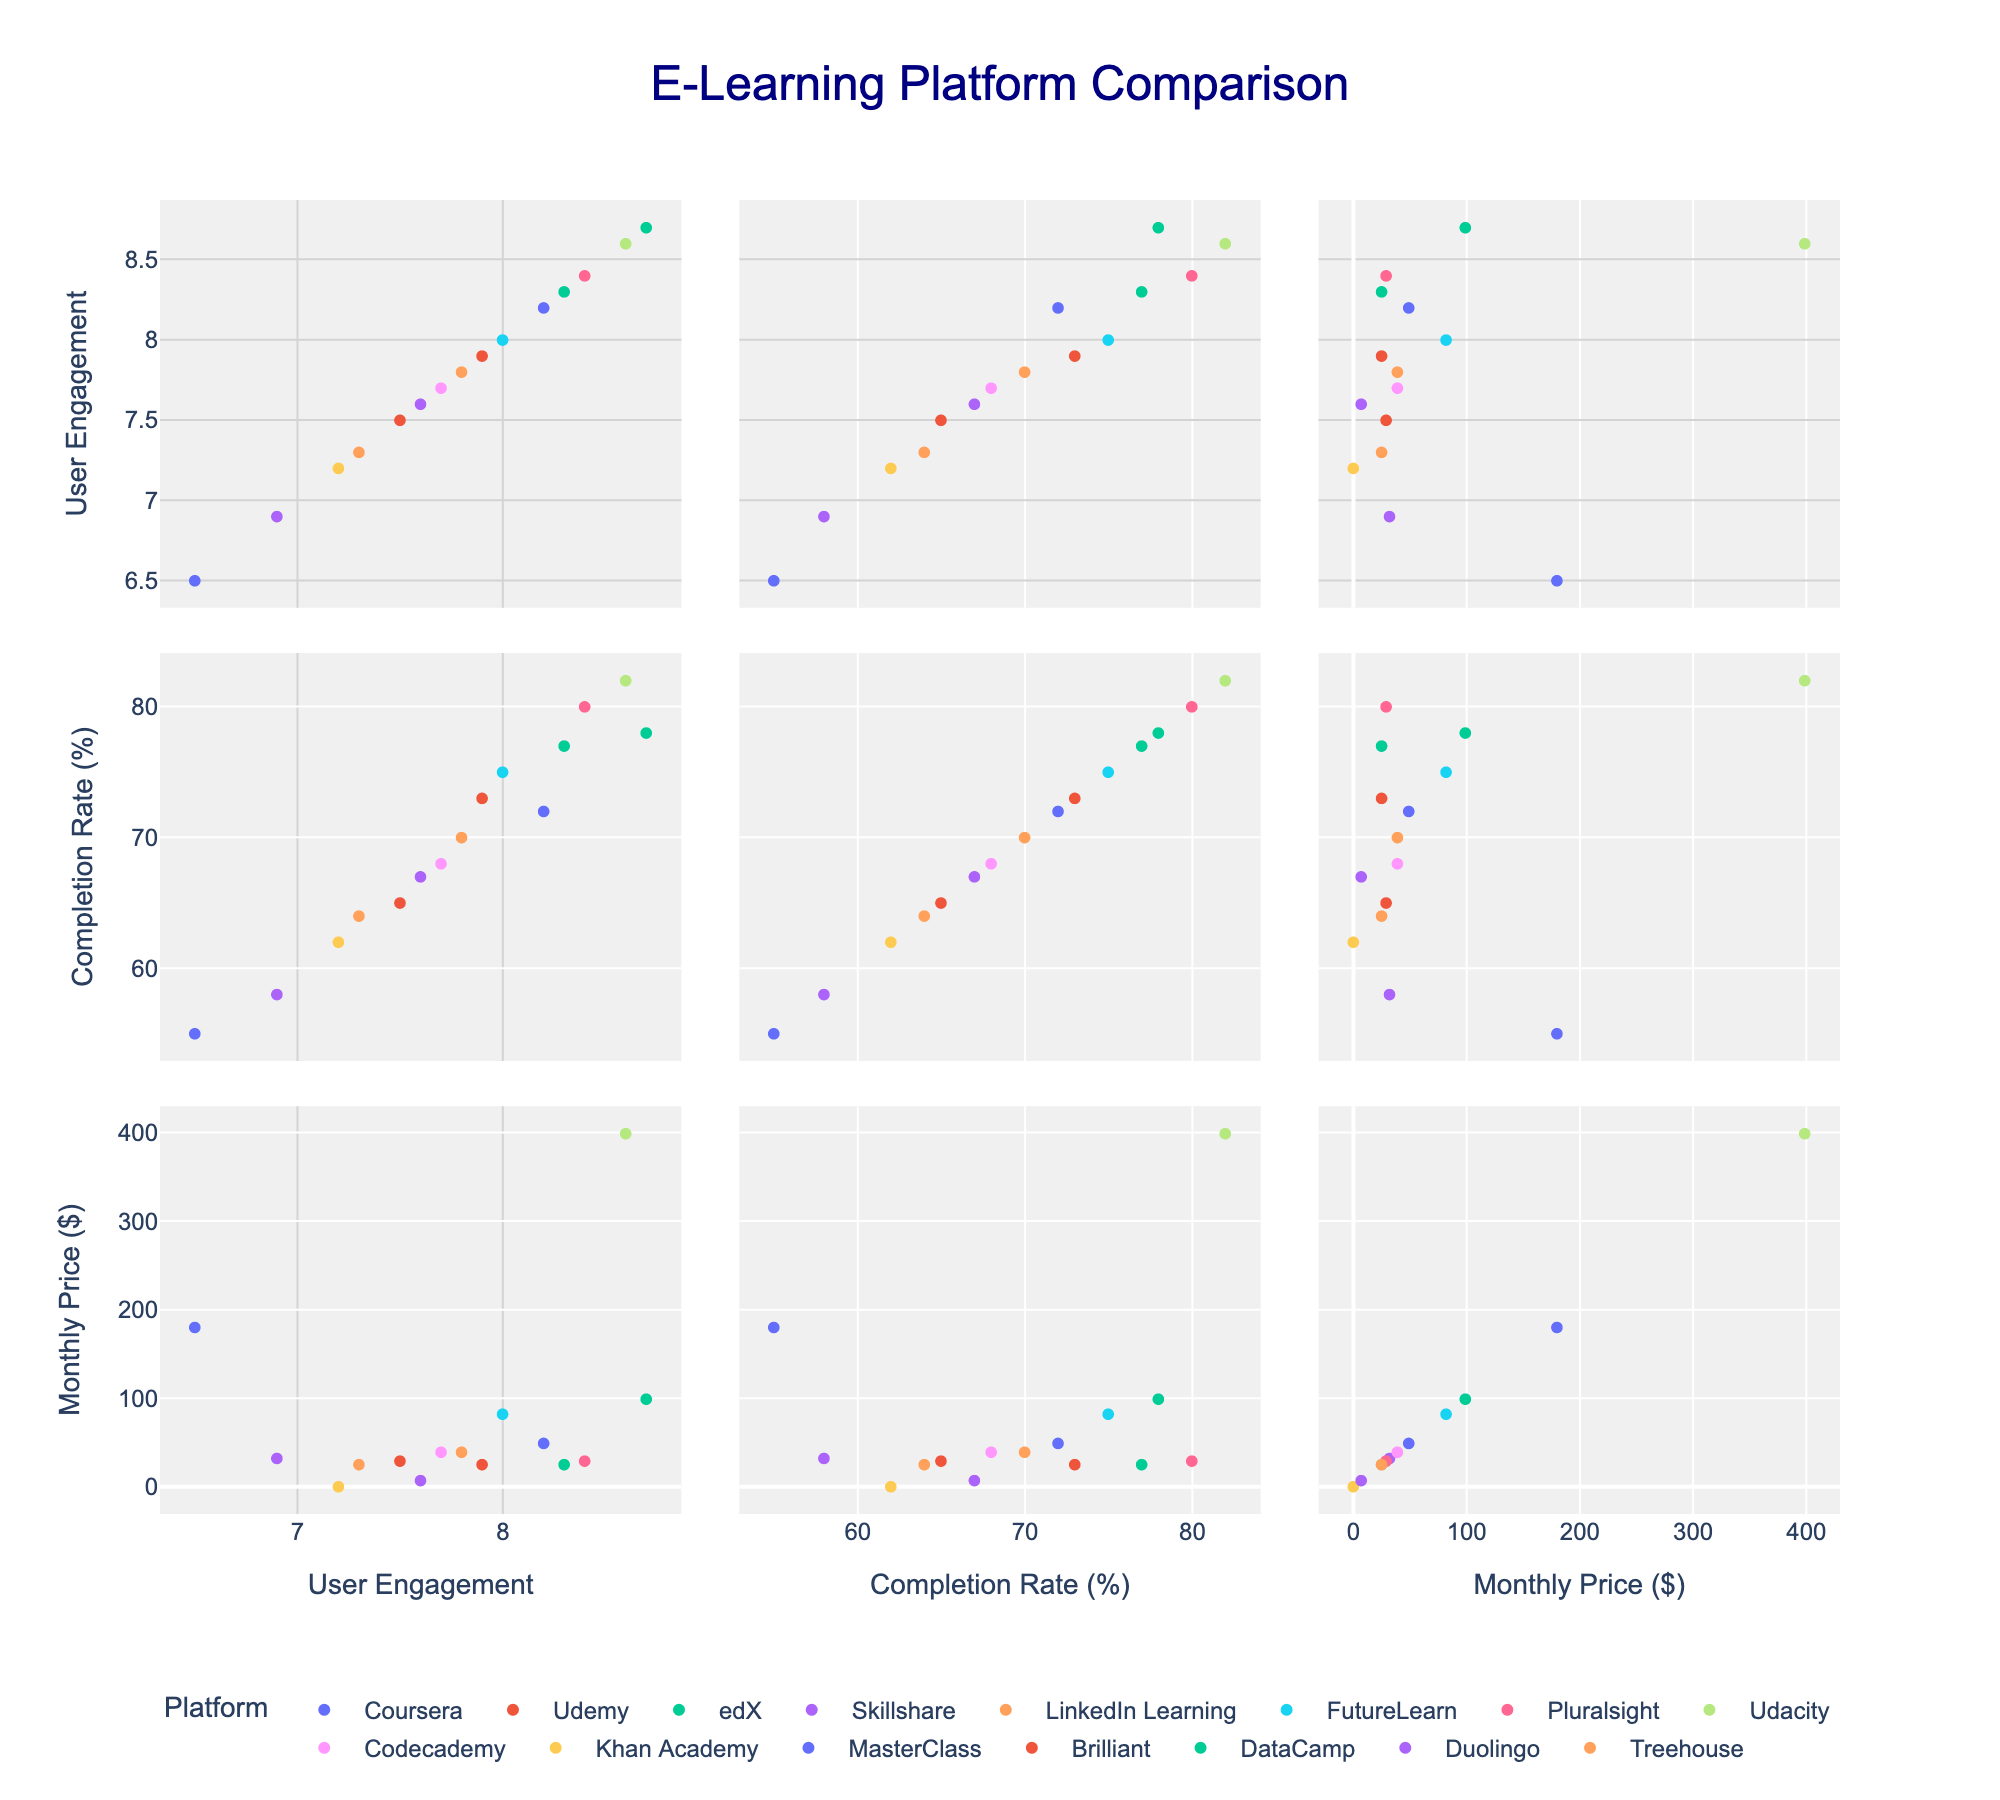What's the title of the figure? The title is usually positioned at the top center of the figure, labeled with larger and bold text. Here, "E-Learning Platform Comparison" is displayed as the title.
Answer: E-Learning Platform Comparison How many e-learning platforms are shown in the scatterplot matrix? By observing the legend or the various colors representing different platforms, we can count the different e-learning platforms. Here, the total number of platforms is 15.
Answer: 15 Which platform has the highest course completion rate? By looking at the "Course Completion Rate" dimension of the scatterplot matrix, we identify the platform with the dot that is farthest to the right. Udacity reaches an 82% completion rate, which is the highest.
Answer: Udacity Which e-learning platform has the lowest user engagement score? To find this, refer to the column for "User Engagement Score" and see which point is positioned at the lowest value on the x or y axes. MasterClass has the lowest user engagement score of 6.5.
Answer: MasterClass What is the price range among the e-learning platforms? The range is the difference between the maximum and minimum values on the "Monthly Price" axis. The highest monthly price is $399 (Udacity) and the lowest is $0 (Khan Academy). Therefore, the range is $399 - $0 = $399.
Answer: $399 Which two platforms have similar user engagement scores but differ significantly in completion rates? By comparing points horizontally along the "User Engagement Score" axis, we find that Pluralsight (8.4) and DataCamp (8.3) have similar engagement scores. However, their course completion rates are 80% and 77%, respectively, which is a notable difference.
Answer: Pluralsight and DataCamp Which platform offers a low monthly price and maintains a high course completion rate? We evaluate platforms positioned low on the "Monthly Price" axis while also being high on the "Course Completion Rate" axis. Pluralsight, priced at $29 with an 80% completion rate, fits this criterion.
Answer: Pluralsight Do more expensive platforms generally show higher user engagement? We compare points along the "Monthly Price" and "User Engagement Score" dimensions. Expensive platforms like Udacity showcase high user engagement (8.6), but more affordable platforms such as edX also show high engagement (8.7). Therefore, there is no consistent trend indicating that higher prices lead to higher user engagement across all platforms.
Answer: No consistent trend Which two platforms have the same monthly price but different user engagement scores? By checking for overlapping points along the "Monthly Price" axis, we see that Codecademy and LinkedIn Learning both have a monthly price of $39. Their user engagement scores differ at 7.7 and 7.8, respectively.
Answer: Codecademy and LinkedIn Learning How many platforms have a monthly price of $25? We scan the "Monthly Price" axis for points representing a value of $25. Three platforms (Brilliant, DataCamp, and Treehouse) match this criterion.
Answer: 3 